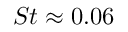Convert formula to latex. <formula><loc_0><loc_0><loc_500><loc_500>S t \approx 0 . 0 6</formula> 